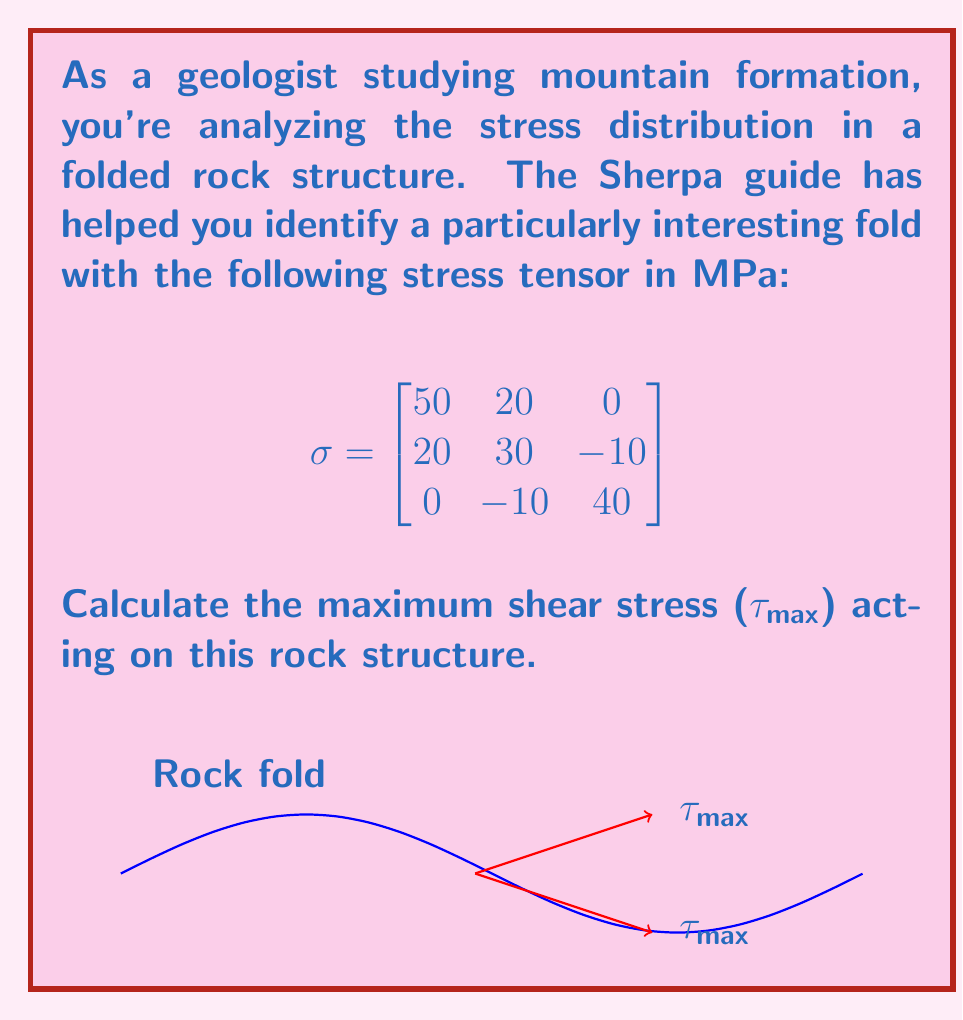Show me your answer to this math problem. To find the maximum shear stress (τ_max), we need to follow these steps:

1) First, we need to find the principal stresses. These are the eigenvalues of the stress tensor.

2) The characteristic equation is:
   $$det(\sigma - \lambda I) = 0$$

3) Expanding this:
   $$(50-\lambda)(30-\lambda)(40-\lambda) - 20^2(40-\lambda) - (-10)^2(50-\lambda) = 0$$

4) This simplifies to:
   $$-\lambda^3 + 120\lambda^2 - 4100\lambda + 39000 = 0$$

5) Solving this cubic equation (using a calculator or computer algebra system) gives:
   $$\lambda_1 \approx 65.68, \lambda_2 \approx 38.16, \lambda_3 \approx 16.16$$

6) These are our principal stresses: σ_1, σ_2, and σ_3 respectively.

7) The maximum shear stress is given by the formula:
   $$\tau_{max} = \frac{\sigma_1 - \sigma_3}{2}$$

8) Substituting our values:
   $$\tau_{max} = \frac{65.68 - 16.16}{2} = 24.76 \text{ MPa}$$

Therefore, the maximum shear stress acting on this rock structure is approximately 24.76 MPa.
Answer: $24.76 \text{ MPa}$ 